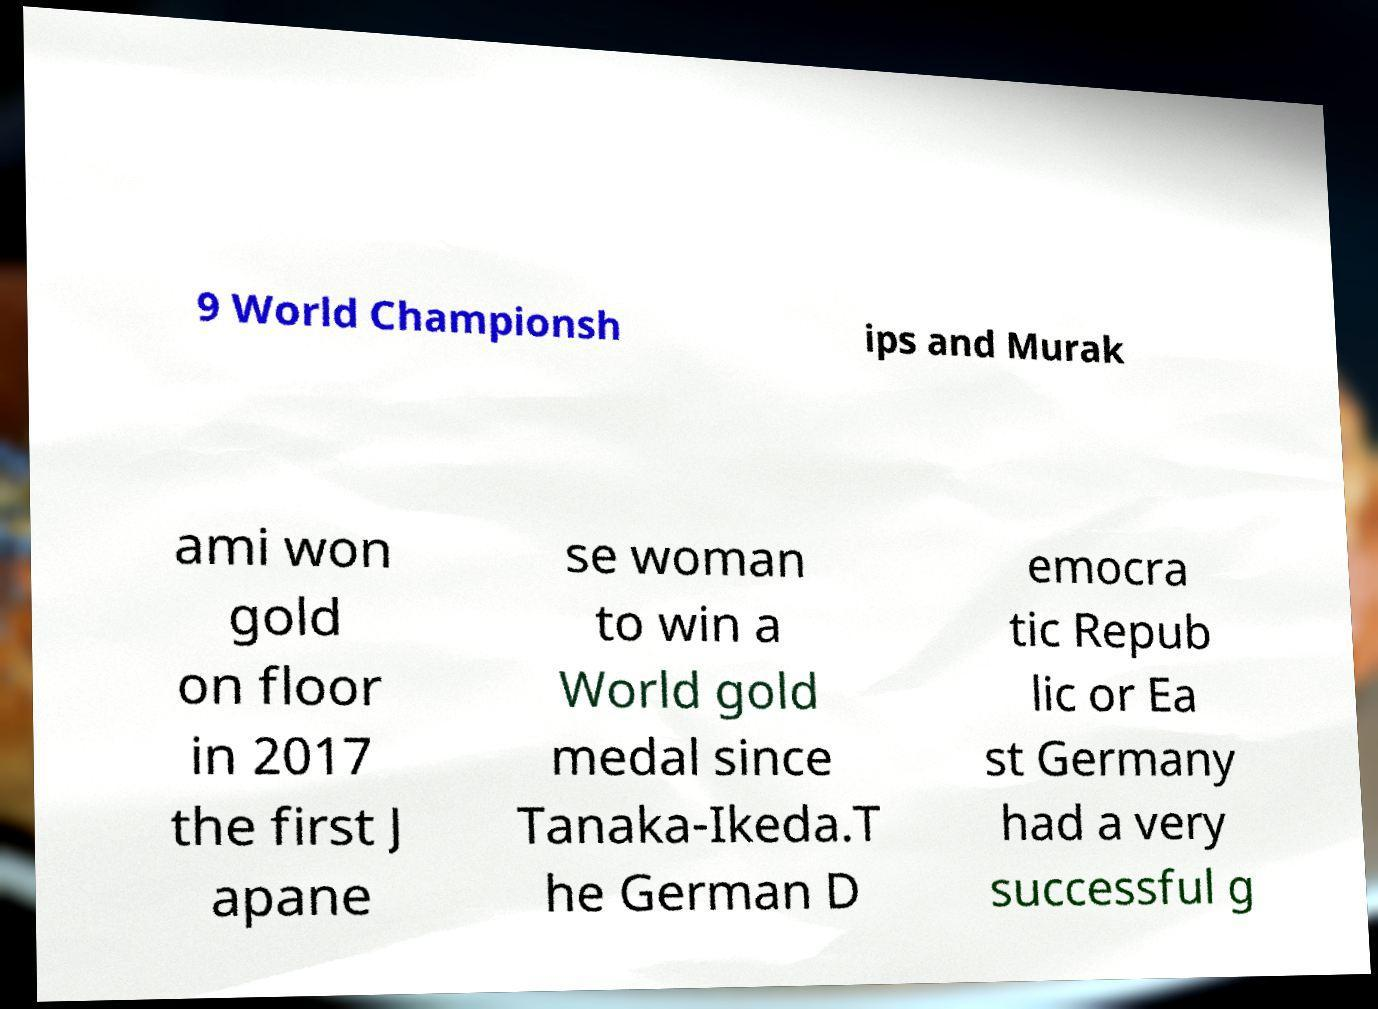What messages or text are displayed in this image? I need them in a readable, typed format. 9 World Championsh ips and Murak ami won gold on floor in 2017 the first J apane se woman to win a World gold medal since Tanaka-Ikeda.T he German D emocra tic Repub lic or Ea st Germany had a very successful g 